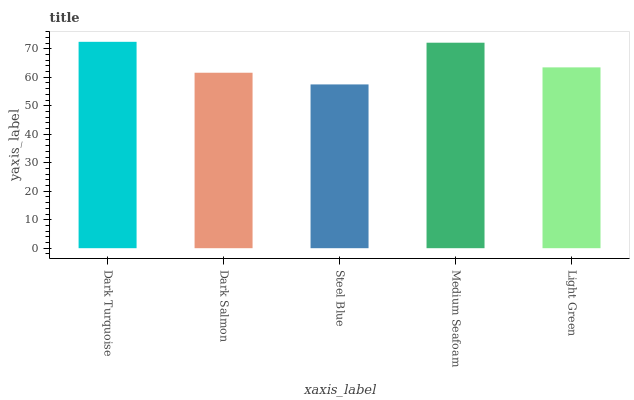Is Steel Blue the minimum?
Answer yes or no. Yes. Is Dark Turquoise the maximum?
Answer yes or no. Yes. Is Dark Salmon the minimum?
Answer yes or no. No. Is Dark Salmon the maximum?
Answer yes or no. No. Is Dark Turquoise greater than Dark Salmon?
Answer yes or no. Yes. Is Dark Salmon less than Dark Turquoise?
Answer yes or no. Yes. Is Dark Salmon greater than Dark Turquoise?
Answer yes or no. No. Is Dark Turquoise less than Dark Salmon?
Answer yes or no. No. Is Light Green the high median?
Answer yes or no. Yes. Is Light Green the low median?
Answer yes or no. Yes. Is Steel Blue the high median?
Answer yes or no. No. Is Dark Salmon the low median?
Answer yes or no. No. 